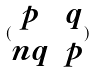Convert formula to latex. <formula><loc_0><loc_0><loc_500><loc_500>( \begin{matrix} p & q \\ n q & p \end{matrix} )</formula> 